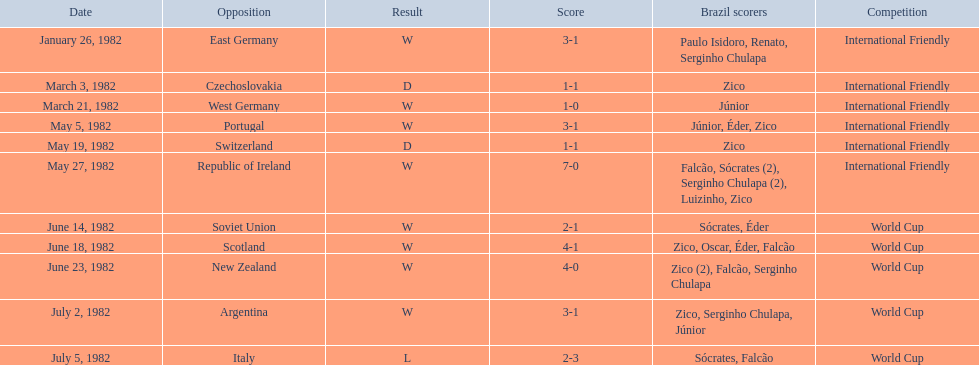Would you be able to parse every entry in this table? {'header': ['Date', 'Opposition', 'Result', 'Score', 'Brazil scorers', 'Competition'], 'rows': [['January 26, 1982', 'East Germany', 'W', '3-1', 'Paulo Isidoro, Renato, Serginho Chulapa', 'International Friendly'], ['March 3, 1982', 'Czechoslovakia', 'D', '1-1', 'Zico', 'International Friendly'], ['March 21, 1982', 'West Germany', 'W', '1-0', 'Júnior', 'International Friendly'], ['May 5, 1982', 'Portugal', 'W', '3-1', 'Júnior, Éder, Zico', 'International Friendly'], ['May 19, 1982', 'Switzerland', 'D', '1-1', 'Zico', 'International Friendly'], ['May 27, 1982', 'Republic of Ireland', 'W', '7-0', 'Falcão, Sócrates (2), Serginho Chulapa (2), Luizinho, Zico', 'International Friendly'], ['June 14, 1982', 'Soviet Union', 'W', '2-1', 'Sócrates, Éder', 'World Cup'], ['June 18, 1982', 'Scotland', 'W', '4-1', 'Zico, Oscar, Éder, Falcão', 'World Cup'], ['June 23, 1982', 'New Zealand', 'W', '4-0', 'Zico (2), Falcão, Serginho Chulapa', 'World Cup'], ['July 2, 1982', 'Argentina', 'W', '3-1', 'Zico, Serginho Chulapa, Júnior', 'World Cup'], ['July 5, 1982', 'Italy', 'L', '2-3', 'Sócrates, Falcão', 'World Cup']]} What are the specific days? January 26, 1982, March 3, 1982, March 21, 1982, May 5, 1982, May 19, 1982, May 27, 1982, June 14, 1982, June 18, 1982, June 23, 1982, July 2, 1982, July 5, 1982. And which day is mentioned initially? January 26, 1982. 